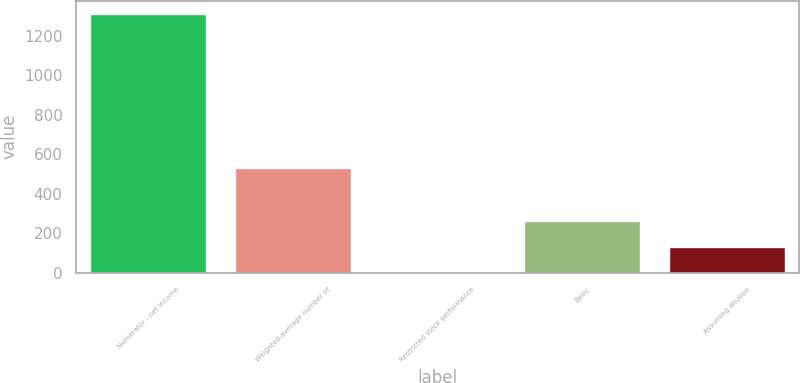<chart> <loc_0><loc_0><loc_500><loc_500><bar_chart><fcel>Numerator - net income<fcel>Weighted-average number of<fcel>Restricted stock performance<fcel>Basic<fcel>Assuming dilution<nl><fcel>1312<fcel>528.61<fcel>2.9<fcel>264.72<fcel>133.81<nl></chart> 